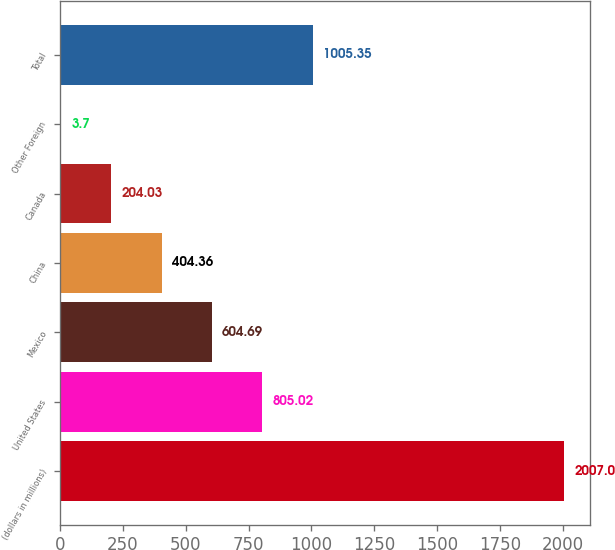<chart> <loc_0><loc_0><loc_500><loc_500><bar_chart><fcel>(dollars in millions)<fcel>United States<fcel>Mexico<fcel>China<fcel>Canada<fcel>Other Foreign<fcel>Total<nl><fcel>2007<fcel>805.02<fcel>604.69<fcel>404.36<fcel>204.03<fcel>3.7<fcel>1005.35<nl></chart> 